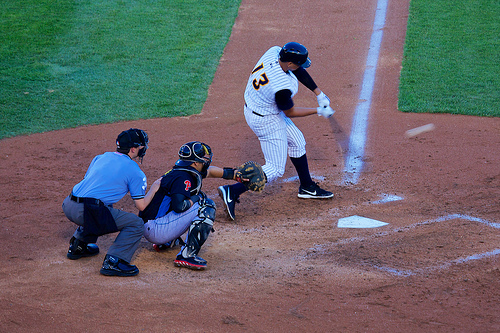What do the expressions and body language of the umpire and catcher tell about the current game situation? Their expressions and body language, focused and tense, indicate that the game is at a critical juncture. The umpire’s intense observation and the catcher’s readiness to act suggest a key moment, likely with significant implications on the game's outcome. 